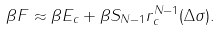Convert formula to latex. <formula><loc_0><loc_0><loc_500><loc_500>\beta F \approx \beta E _ { c } + \beta S _ { N - 1 } r _ { c } ^ { N - 1 } ( \Delta \sigma ) .</formula> 